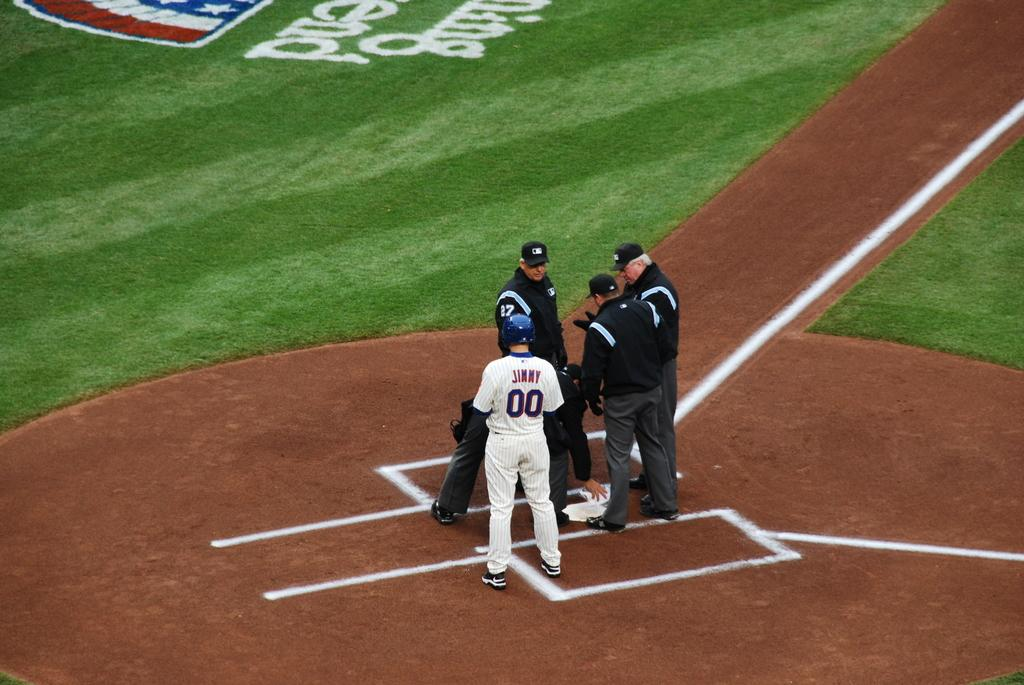<image>
Create a compact narrative representing the image presented. baseball player 00 stands on home plate near some baseball managers 